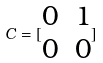Convert formula to latex. <formula><loc_0><loc_0><loc_500><loc_500>C = [ \begin{matrix} 0 & 1 \\ 0 & 0 \end{matrix} ]</formula> 